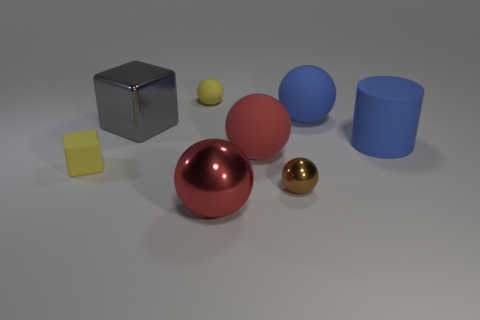Subtract all yellow spheres. How many spheres are left? 4 Subtract all yellow matte balls. How many balls are left? 4 Subtract all blocks. How many objects are left? 6 Add 1 large objects. How many large objects are left? 6 Add 3 tiny spheres. How many tiny spheres exist? 5 Add 1 big matte objects. How many objects exist? 9 Subtract 0 gray balls. How many objects are left? 8 Subtract 1 cubes. How many cubes are left? 1 Subtract all purple blocks. Subtract all cyan balls. How many blocks are left? 2 Subtract all red blocks. How many brown balls are left? 1 